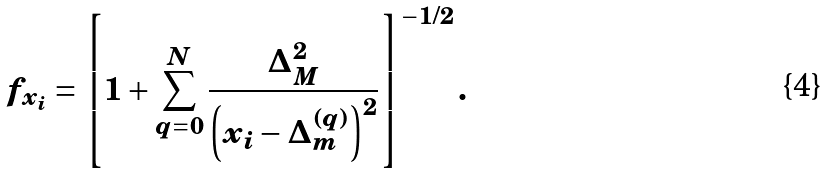<formula> <loc_0><loc_0><loc_500><loc_500>f _ { x _ { i } } = \left [ 1 + \sum _ { q = 0 } ^ { N } \frac { \Delta _ { M } ^ { 2 } } { \left ( x _ { i } - \Delta _ { m } ^ { ( q ) } \right ) ^ { 2 } } \right ] ^ { - 1 / 2 } .</formula> 